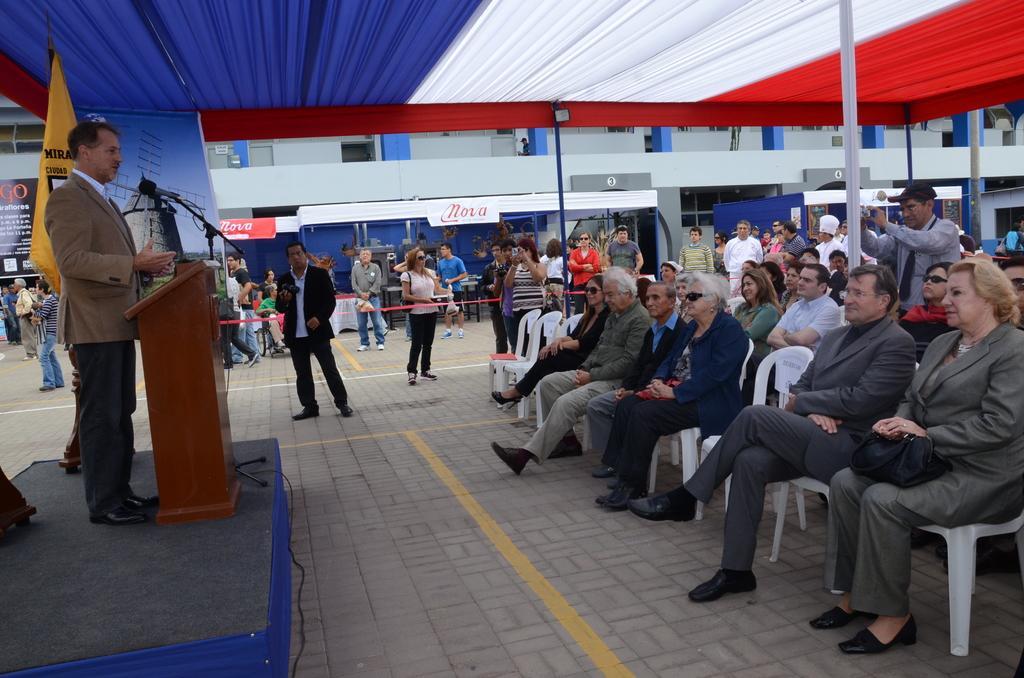Describe this image in one or two sentences. At the right side of the image there are people sitting on chairs. At the left side of the image there is a person standing wearing a suit. In the center of the image there are people. In the background of the image there is a building. At the bottom of the image there is a road. 